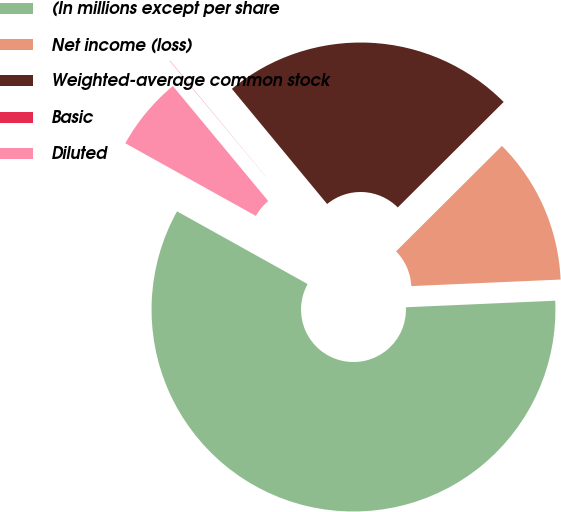<chart> <loc_0><loc_0><loc_500><loc_500><pie_chart><fcel>(In millions except per share<fcel>Net income (loss)<fcel>Weighted-average common stock<fcel>Basic<fcel>Diluted<nl><fcel>58.78%<fcel>11.77%<fcel>23.53%<fcel>0.02%<fcel>5.9%<nl></chart> 